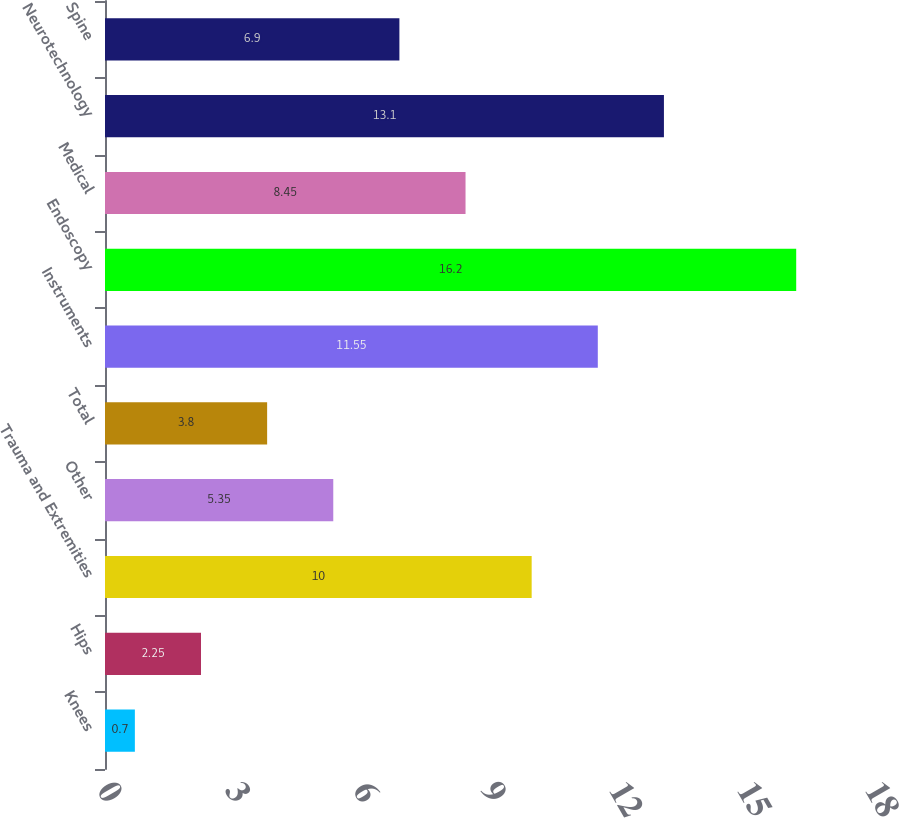<chart> <loc_0><loc_0><loc_500><loc_500><bar_chart><fcel>Knees<fcel>Hips<fcel>Trauma and Extremities<fcel>Other<fcel>Total<fcel>Instruments<fcel>Endoscopy<fcel>Medical<fcel>Neurotechnology<fcel>Spine<nl><fcel>0.7<fcel>2.25<fcel>10<fcel>5.35<fcel>3.8<fcel>11.55<fcel>16.2<fcel>8.45<fcel>13.1<fcel>6.9<nl></chart> 